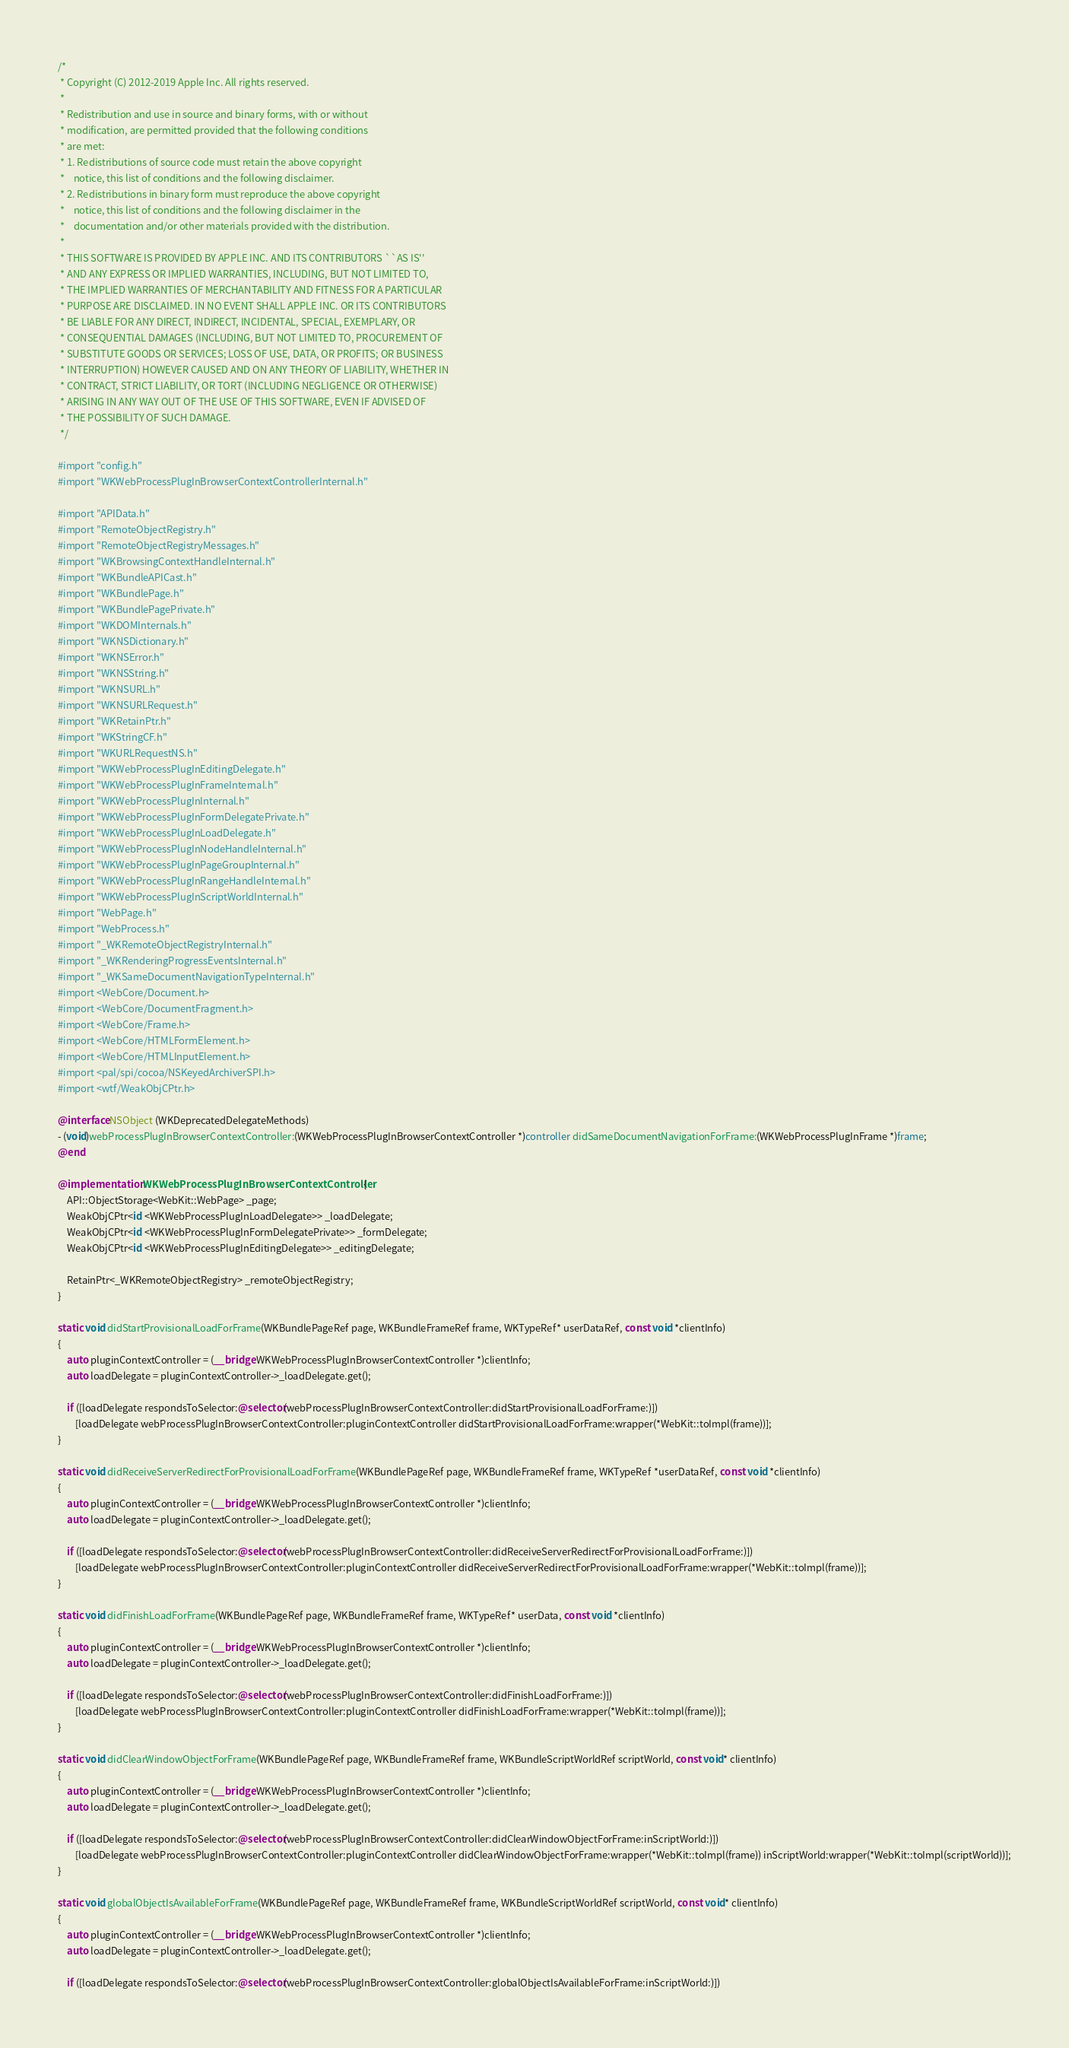<code> <loc_0><loc_0><loc_500><loc_500><_ObjectiveC_>/*
 * Copyright (C) 2012-2019 Apple Inc. All rights reserved.
 *
 * Redistribution and use in source and binary forms, with or without
 * modification, are permitted provided that the following conditions
 * are met:
 * 1. Redistributions of source code must retain the above copyright
 *    notice, this list of conditions and the following disclaimer.
 * 2. Redistributions in binary form must reproduce the above copyright
 *    notice, this list of conditions and the following disclaimer in the
 *    documentation and/or other materials provided with the distribution.
 *
 * THIS SOFTWARE IS PROVIDED BY APPLE INC. AND ITS CONTRIBUTORS ``AS IS''
 * AND ANY EXPRESS OR IMPLIED WARRANTIES, INCLUDING, BUT NOT LIMITED TO,
 * THE IMPLIED WARRANTIES OF MERCHANTABILITY AND FITNESS FOR A PARTICULAR
 * PURPOSE ARE DISCLAIMED. IN NO EVENT SHALL APPLE INC. OR ITS CONTRIBUTORS
 * BE LIABLE FOR ANY DIRECT, INDIRECT, INCIDENTAL, SPECIAL, EXEMPLARY, OR
 * CONSEQUENTIAL DAMAGES (INCLUDING, BUT NOT LIMITED TO, PROCUREMENT OF
 * SUBSTITUTE GOODS OR SERVICES; LOSS OF USE, DATA, OR PROFITS; OR BUSINESS
 * INTERRUPTION) HOWEVER CAUSED AND ON ANY THEORY OF LIABILITY, WHETHER IN
 * CONTRACT, STRICT LIABILITY, OR TORT (INCLUDING NEGLIGENCE OR OTHERWISE)
 * ARISING IN ANY WAY OUT OF THE USE OF THIS SOFTWARE, EVEN IF ADVISED OF
 * THE POSSIBILITY OF SUCH DAMAGE.
 */

#import "config.h"
#import "WKWebProcessPlugInBrowserContextControllerInternal.h"

#import "APIData.h"
#import "RemoteObjectRegistry.h"
#import "RemoteObjectRegistryMessages.h"
#import "WKBrowsingContextHandleInternal.h"
#import "WKBundleAPICast.h"
#import "WKBundlePage.h"
#import "WKBundlePagePrivate.h"
#import "WKDOMInternals.h"
#import "WKNSDictionary.h"
#import "WKNSError.h"
#import "WKNSString.h"
#import "WKNSURL.h"
#import "WKNSURLRequest.h"
#import "WKRetainPtr.h"
#import "WKStringCF.h"
#import "WKURLRequestNS.h"
#import "WKWebProcessPlugInEditingDelegate.h"
#import "WKWebProcessPlugInFrameInternal.h"
#import "WKWebProcessPlugInInternal.h"
#import "WKWebProcessPlugInFormDelegatePrivate.h"
#import "WKWebProcessPlugInLoadDelegate.h"
#import "WKWebProcessPlugInNodeHandleInternal.h"
#import "WKWebProcessPlugInPageGroupInternal.h"
#import "WKWebProcessPlugInRangeHandleInternal.h"
#import "WKWebProcessPlugInScriptWorldInternal.h"
#import "WebPage.h"
#import "WebProcess.h"
#import "_WKRemoteObjectRegistryInternal.h"
#import "_WKRenderingProgressEventsInternal.h"
#import "_WKSameDocumentNavigationTypeInternal.h"
#import <WebCore/Document.h>
#import <WebCore/DocumentFragment.h>
#import <WebCore/Frame.h>
#import <WebCore/HTMLFormElement.h>
#import <WebCore/HTMLInputElement.h>
#import <pal/spi/cocoa/NSKeyedArchiverSPI.h>
#import <wtf/WeakObjCPtr.h>

@interface NSObject (WKDeprecatedDelegateMethods)
- (void)webProcessPlugInBrowserContextController:(WKWebProcessPlugInBrowserContextController *)controller didSameDocumentNavigationForFrame:(WKWebProcessPlugInFrame *)frame;
@end

@implementation WKWebProcessPlugInBrowserContextController {
    API::ObjectStorage<WebKit::WebPage> _page;
    WeakObjCPtr<id <WKWebProcessPlugInLoadDelegate>> _loadDelegate;
    WeakObjCPtr<id <WKWebProcessPlugInFormDelegatePrivate>> _formDelegate;
    WeakObjCPtr<id <WKWebProcessPlugInEditingDelegate>> _editingDelegate;
    
    RetainPtr<_WKRemoteObjectRegistry> _remoteObjectRegistry;
}

static void didStartProvisionalLoadForFrame(WKBundlePageRef page, WKBundleFrameRef frame, WKTypeRef* userDataRef, const void *clientInfo)
{
    auto pluginContextController = (__bridge WKWebProcessPlugInBrowserContextController *)clientInfo;
    auto loadDelegate = pluginContextController->_loadDelegate.get();

    if ([loadDelegate respondsToSelector:@selector(webProcessPlugInBrowserContextController:didStartProvisionalLoadForFrame:)])
        [loadDelegate webProcessPlugInBrowserContextController:pluginContextController didStartProvisionalLoadForFrame:wrapper(*WebKit::toImpl(frame))];
}

static void didReceiveServerRedirectForProvisionalLoadForFrame(WKBundlePageRef page, WKBundleFrameRef frame, WKTypeRef *userDataRef, const void *clientInfo)
{
    auto pluginContextController = (__bridge WKWebProcessPlugInBrowserContextController *)clientInfo;
    auto loadDelegate = pluginContextController->_loadDelegate.get();

    if ([loadDelegate respondsToSelector:@selector(webProcessPlugInBrowserContextController:didReceiveServerRedirectForProvisionalLoadForFrame:)])
        [loadDelegate webProcessPlugInBrowserContextController:pluginContextController didReceiveServerRedirectForProvisionalLoadForFrame:wrapper(*WebKit::toImpl(frame))];
}

static void didFinishLoadForFrame(WKBundlePageRef page, WKBundleFrameRef frame, WKTypeRef* userData, const void *clientInfo)
{
    auto pluginContextController = (__bridge WKWebProcessPlugInBrowserContextController *)clientInfo;
    auto loadDelegate = pluginContextController->_loadDelegate.get();

    if ([loadDelegate respondsToSelector:@selector(webProcessPlugInBrowserContextController:didFinishLoadForFrame:)])
        [loadDelegate webProcessPlugInBrowserContextController:pluginContextController didFinishLoadForFrame:wrapper(*WebKit::toImpl(frame))];
}

static void didClearWindowObjectForFrame(WKBundlePageRef page, WKBundleFrameRef frame, WKBundleScriptWorldRef scriptWorld, const void* clientInfo)
{
    auto pluginContextController = (__bridge WKWebProcessPlugInBrowserContextController *)clientInfo;
    auto loadDelegate = pluginContextController->_loadDelegate.get();
    
    if ([loadDelegate respondsToSelector:@selector(webProcessPlugInBrowserContextController:didClearWindowObjectForFrame:inScriptWorld:)])
        [loadDelegate webProcessPlugInBrowserContextController:pluginContextController didClearWindowObjectForFrame:wrapper(*WebKit::toImpl(frame)) inScriptWorld:wrapper(*WebKit::toImpl(scriptWorld))];
}

static void globalObjectIsAvailableForFrame(WKBundlePageRef page, WKBundleFrameRef frame, WKBundleScriptWorldRef scriptWorld, const void* clientInfo)
{
    auto pluginContextController = (__bridge WKWebProcessPlugInBrowserContextController *)clientInfo;
    auto loadDelegate = pluginContextController->_loadDelegate.get();

    if ([loadDelegate respondsToSelector:@selector(webProcessPlugInBrowserContextController:globalObjectIsAvailableForFrame:inScriptWorld:)])</code> 